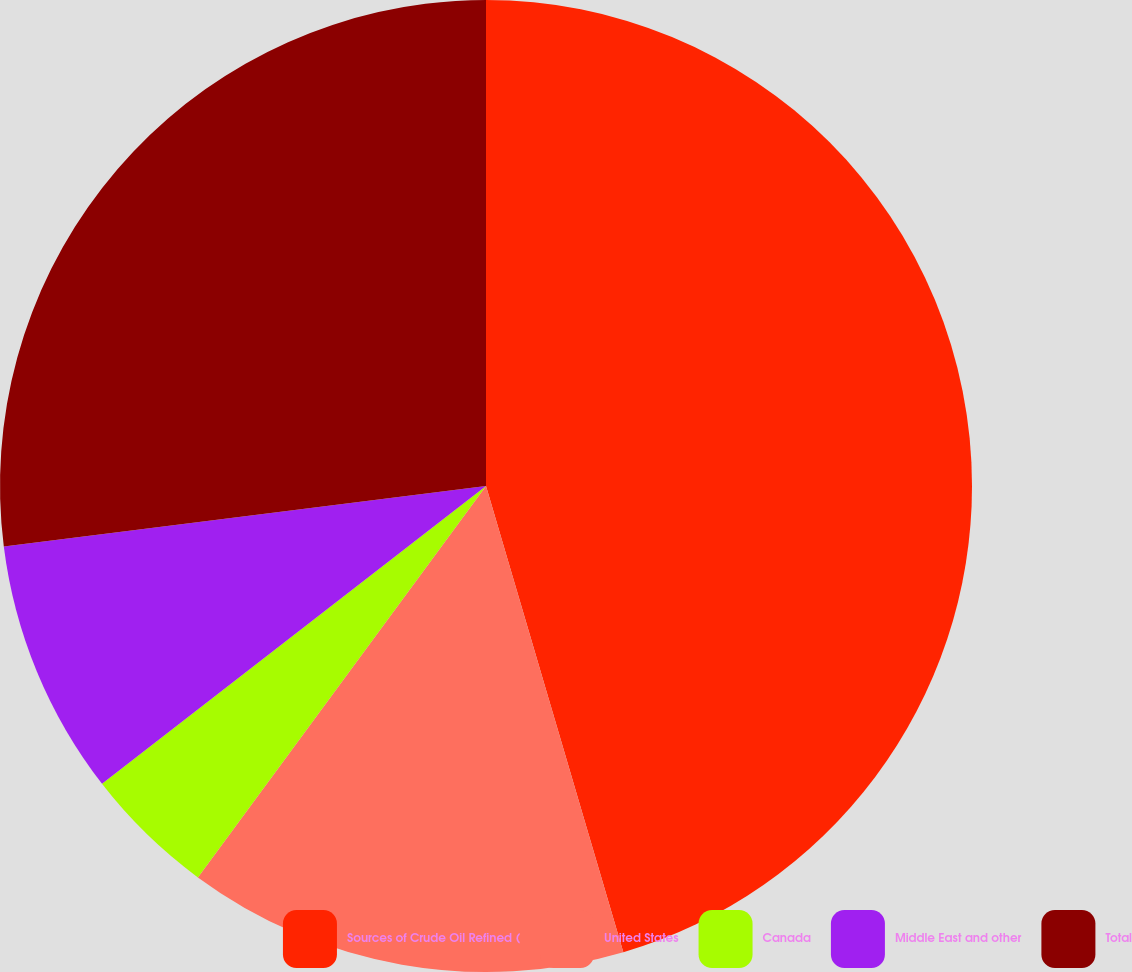<chart> <loc_0><loc_0><loc_500><loc_500><pie_chart><fcel>Sources of Crude Oil Refined (<fcel>United States<fcel>Canada<fcel>Middle East and other<fcel>Total<nl><fcel>45.44%<fcel>14.66%<fcel>4.4%<fcel>8.51%<fcel>26.99%<nl></chart> 